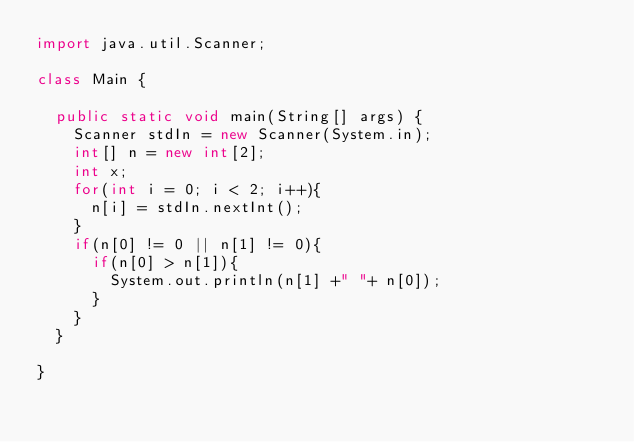Convert code to text. <code><loc_0><loc_0><loc_500><loc_500><_Java_>import java.util.Scanner;

class Main {

	public static void main(String[] args) {
		Scanner stdIn = new Scanner(System.in);
		int[] n = new int[2];
		int x;
		for(int i = 0; i < 2; i++){
			n[i] = stdIn.nextInt();
		}
		if(n[0] != 0 || n[1] != 0){
			if(n[0] > n[1]){
				System.out.println(n[1] +" "+ n[0]);
			}
		}
	}

}</code> 